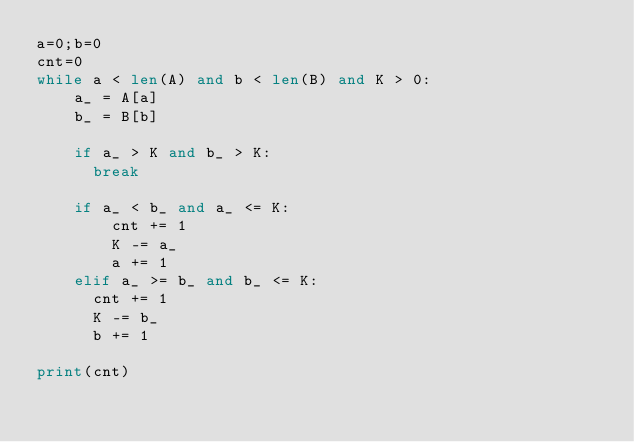Convert code to text. <code><loc_0><loc_0><loc_500><loc_500><_Python_>a=0;b=0
cnt=0
while a < len(A) and b < len(B) and K > 0:
	a_ = A[a]
	b_ = B[b]
    
    if a_ > K and b_ > K:
      break
      
    if a_ < b_ and a_ <= K:
		cnt += 1
		K -= a_
        a += 1
	elif a_ >= b_ and b_ <= K:
      cnt += 1
      K -= b_
      b += 1
      
print(cnt)  </code> 